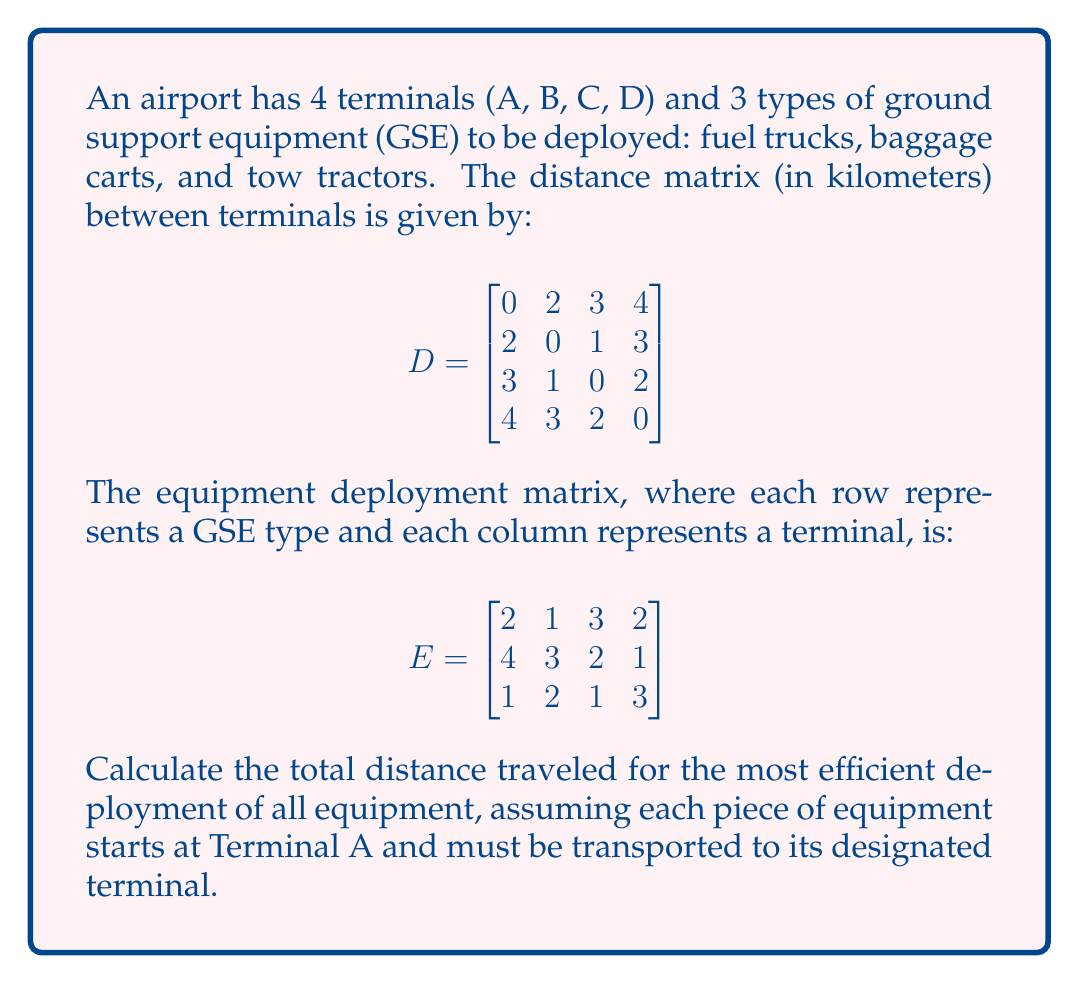Teach me how to tackle this problem. To solve this problem, we'll follow these steps:

1) First, we need to calculate the total number of trips from Terminal A to each other terminal. We can do this by summing the columns of matrix E, excluding the first column (Terminal A):

   $$\text{Trips} = [1 + 3 + 2, 3 + 2 + 1, 2 + 1 + 3] = [6, 6, 6]$$

2) Now, we need to multiply these trips by the distances from Terminal A to each other terminal. We can find these distances in the first row of matrix D, excluding the first element:

   $$\text{Distances from A} = [2, 3, 4]$$

3) To get the total distance, we multiply each number of trips by its corresponding distance and sum the results:

   $$\text{Total Distance} = (6 \times 2) + (6 \times 3) + (6 \times 4) = 12 + 18 + 24 = 54$$

Therefore, the most efficient deployment route requires a total travel distance of 54 kilometers.
Answer: 54 km 